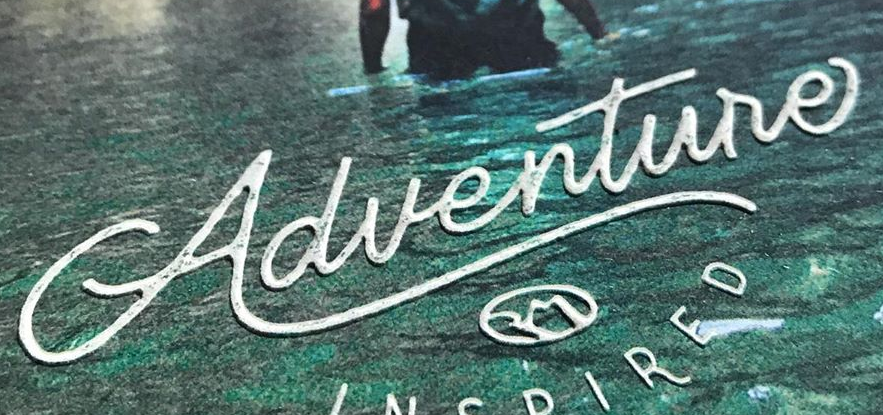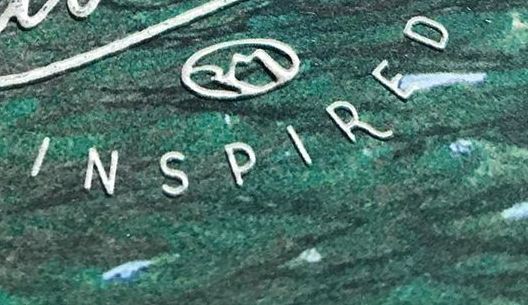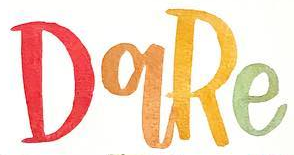What text is displayed in these images sequentially, separated by a semicolon? Adventure; INSPIRED; DqRe 